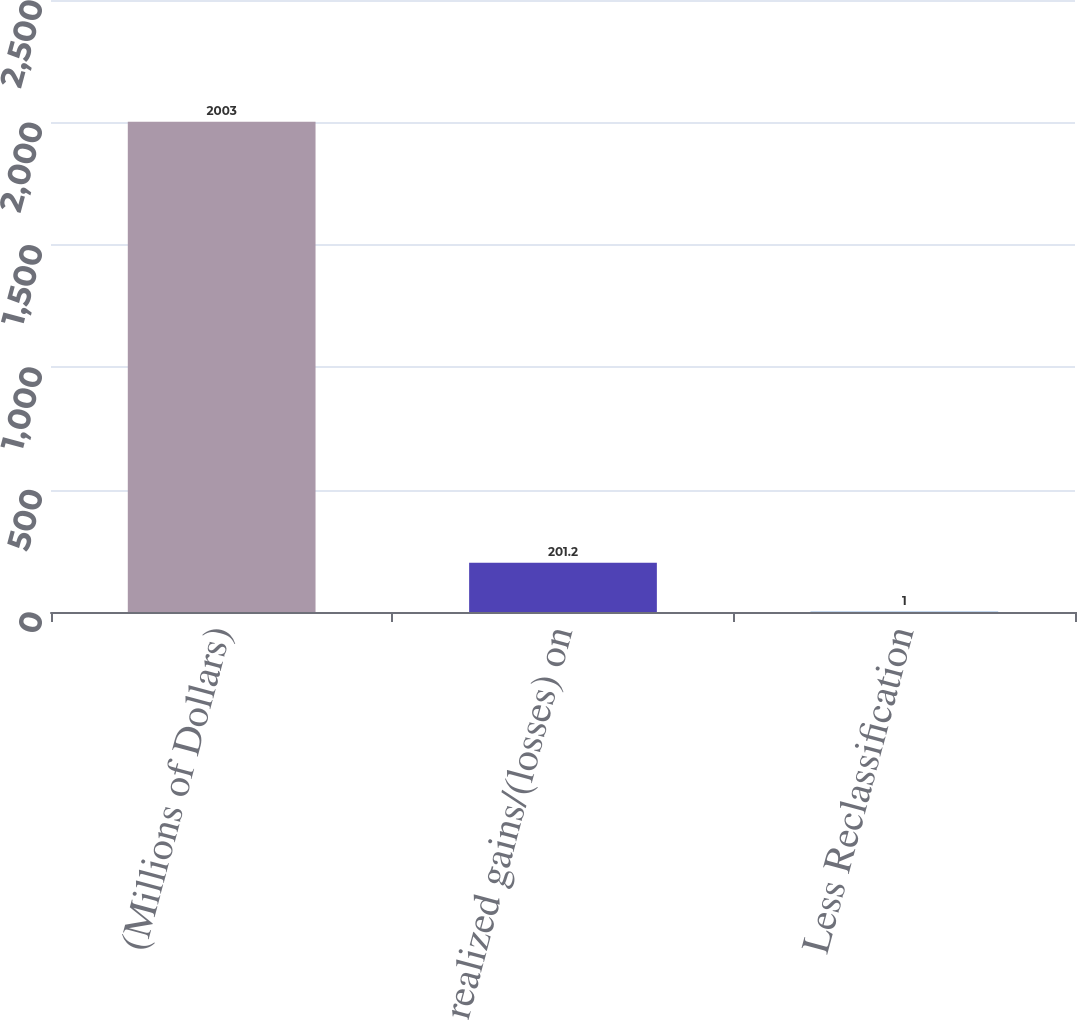Convert chart. <chart><loc_0><loc_0><loc_500><loc_500><bar_chart><fcel>(Millions of Dollars)<fcel>Unrealized gains/(losses) on<fcel>Less Reclassification<nl><fcel>2003<fcel>201.2<fcel>1<nl></chart> 